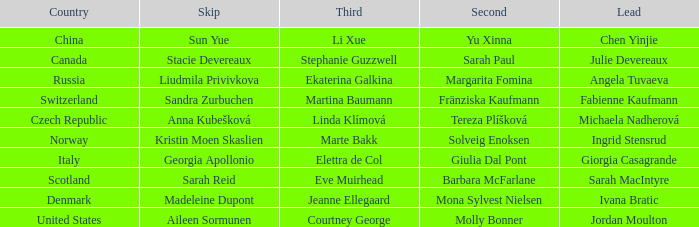What is the second that has jordan moulton as the lead? Molly Bonner. 